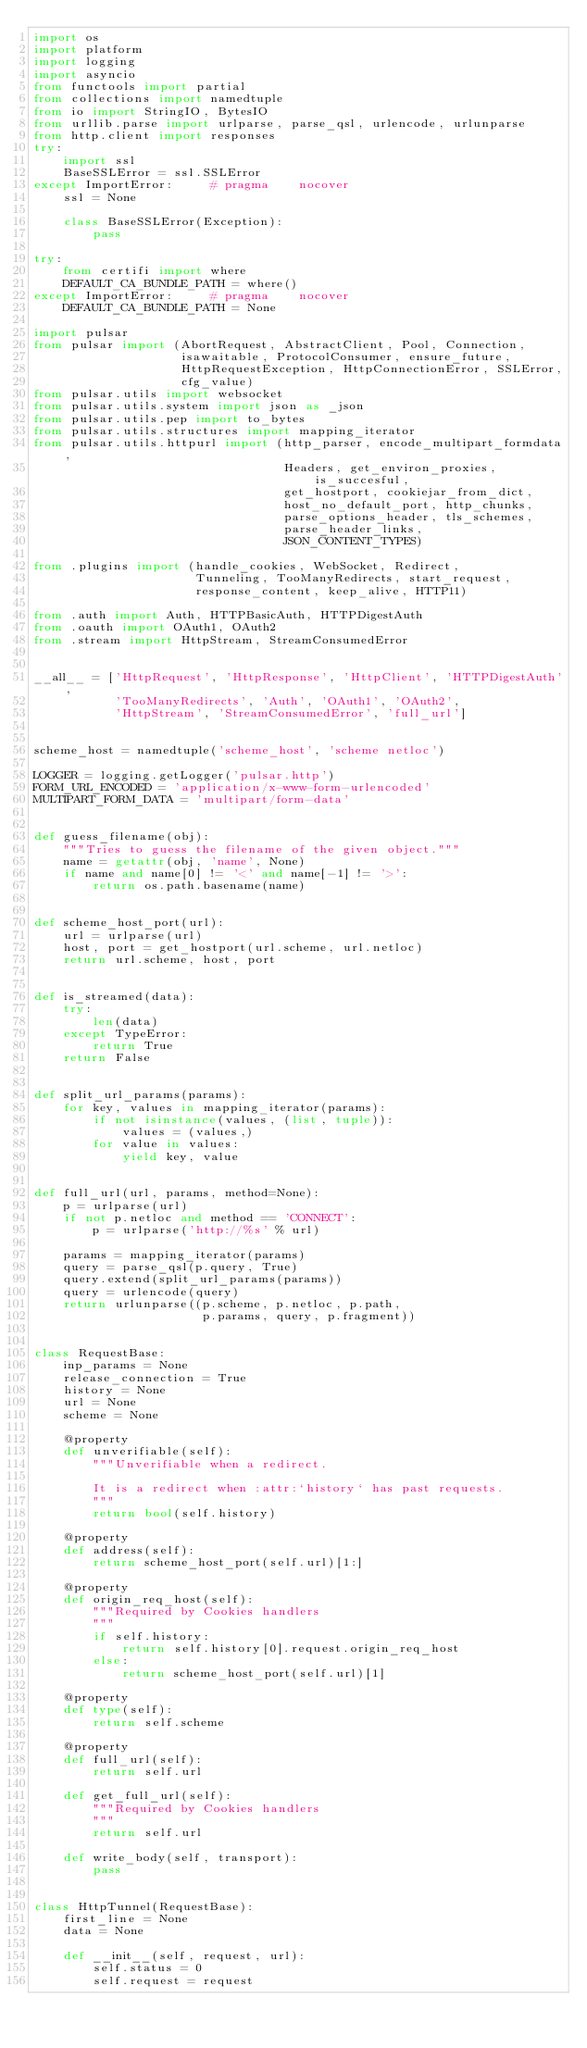Convert code to text. <code><loc_0><loc_0><loc_500><loc_500><_Python_>import os
import platform
import logging
import asyncio
from functools import partial
from collections import namedtuple
from io import StringIO, BytesIO
from urllib.parse import urlparse, parse_qsl, urlencode, urlunparse
from http.client import responses
try:
    import ssl
    BaseSSLError = ssl.SSLError
except ImportError:     # pragma    nocover
    ssl = None

    class BaseSSLError(Exception):
        pass

try:
    from certifi import where
    DEFAULT_CA_BUNDLE_PATH = where()
except ImportError:     # pragma    nocover
    DEFAULT_CA_BUNDLE_PATH = None

import pulsar
from pulsar import (AbortRequest, AbstractClient, Pool, Connection,
                    isawaitable, ProtocolConsumer, ensure_future,
                    HttpRequestException, HttpConnectionError, SSLError,
                    cfg_value)
from pulsar.utils import websocket
from pulsar.utils.system import json as _json
from pulsar.utils.pep import to_bytes
from pulsar.utils.structures import mapping_iterator
from pulsar.utils.httpurl import (http_parser, encode_multipart_formdata,
                                  Headers, get_environ_proxies, is_succesful,
                                  get_hostport, cookiejar_from_dict,
                                  host_no_default_port, http_chunks,
                                  parse_options_header, tls_schemes,
                                  parse_header_links,
                                  JSON_CONTENT_TYPES)

from .plugins import (handle_cookies, WebSocket, Redirect,
                      Tunneling, TooManyRedirects, start_request,
                      response_content, keep_alive, HTTP11)

from .auth import Auth, HTTPBasicAuth, HTTPDigestAuth
from .oauth import OAuth1, OAuth2
from .stream import HttpStream, StreamConsumedError


__all__ = ['HttpRequest', 'HttpResponse', 'HttpClient', 'HTTPDigestAuth',
           'TooManyRedirects', 'Auth', 'OAuth1', 'OAuth2',
           'HttpStream', 'StreamConsumedError', 'full_url']


scheme_host = namedtuple('scheme_host', 'scheme netloc')

LOGGER = logging.getLogger('pulsar.http')
FORM_URL_ENCODED = 'application/x-www-form-urlencoded'
MULTIPART_FORM_DATA = 'multipart/form-data'


def guess_filename(obj):
    """Tries to guess the filename of the given object."""
    name = getattr(obj, 'name', None)
    if name and name[0] != '<' and name[-1] != '>':
        return os.path.basename(name)


def scheme_host_port(url):
    url = urlparse(url)
    host, port = get_hostport(url.scheme, url.netloc)
    return url.scheme, host, port


def is_streamed(data):
    try:
        len(data)
    except TypeError:
        return True
    return False


def split_url_params(params):
    for key, values in mapping_iterator(params):
        if not isinstance(values, (list, tuple)):
            values = (values,)
        for value in values:
            yield key, value


def full_url(url, params, method=None):
    p = urlparse(url)
    if not p.netloc and method == 'CONNECT':
        p = urlparse('http://%s' % url)

    params = mapping_iterator(params)
    query = parse_qsl(p.query, True)
    query.extend(split_url_params(params))
    query = urlencode(query)
    return urlunparse((p.scheme, p.netloc, p.path,
                       p.params, query, p.fragment))


class RequestBase:
    inp_params = None
    release_connection = True
    history = None
    url = None
    scheme = None

    @property
    def unverifiable(self):
        """Unverifiable when a redirect.

        It is a redirect when :attr:`history` has past requests.
        """
        return bool(self.history)

    @property
    def address(self):
        return scheme_host_port(self.url)[1:]

    @property
    def origin_req_host(self):
        """Required by Cookies handlers
        """
        if self.history:
            return self.history[0].request.origin_req_host
        else:
            return scheme_host_port(self.url)[1]

    @property
    def type(self):
        return self.scheme

    @property
    def full_url(self):
        return self.url

    def get_full_url(self):
        """Required by Cookies handlers
        """
        return self.url

    def write_body(self, transport):
        pass


class HttpTunnel(RequestBase):
    first_line = None
    data = None

    def __init__(self, request, url):
        self.status = 0
        self.request = request</code> 